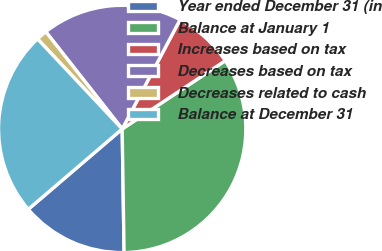Convert chart. <chart><loc_0><loc_0><loc_500><loc_500><pie_chart><fcel>Year ended December 31 (in<fcel>Balance at January 1<fcel>Increases based on tax<fcel>Decreases based on tax<fcel>Decreases related to cash<fcel>Balance at December 31<nl><fcel>13.98%<fcel>34.06%<fcel>7.94%<fcel>18.35%<fcel>1.41%<fcel>24.25%<nl></chart> 